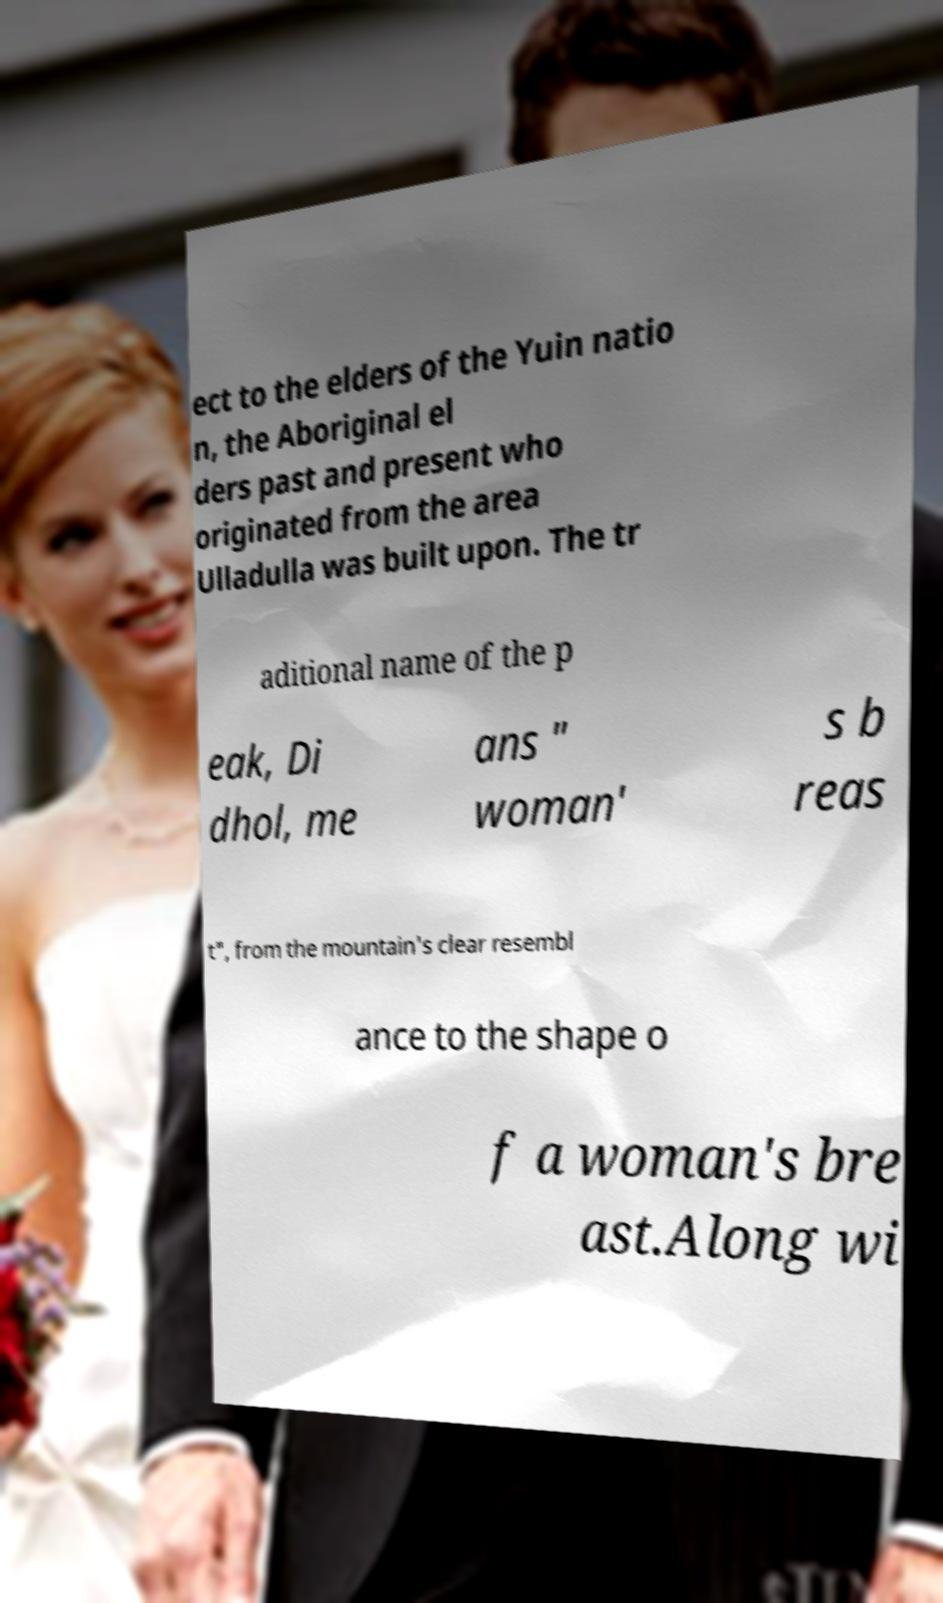For documentation purposes, I need the text within this image transcribed. Could you provide that? ect to the elders of the Yuin natio n, the Aboriginal el ders past and present who originated from the area Ulladulla was built upon. The tr aditional name of the p eak, Di dhol, me ans " woman' s b reas t", from the mountain's clear resembl ance to the shape o f a woman's bre ast.Along wi 